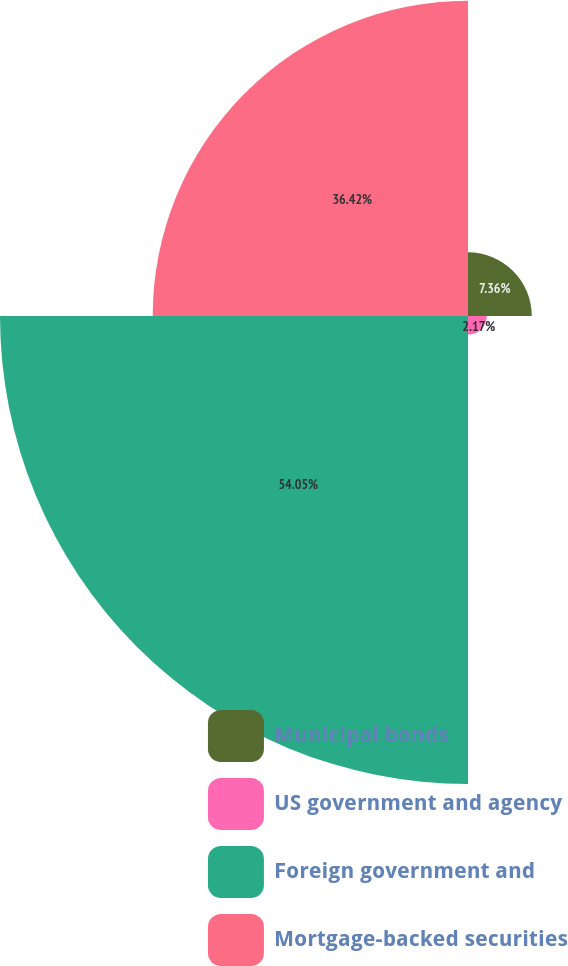Convert chart. <chart><loc_0><loc_0><loc_500><loc_500><pie_chart><fcel>Municipal bonds<fcel>US government and agency<fcel>Foreign government and<fcel>Mortgage-backed securities<nl><fcel>7.36%<fcel>2.17%<fcel>54.06%<fcel>36.42%<nl></chart> 